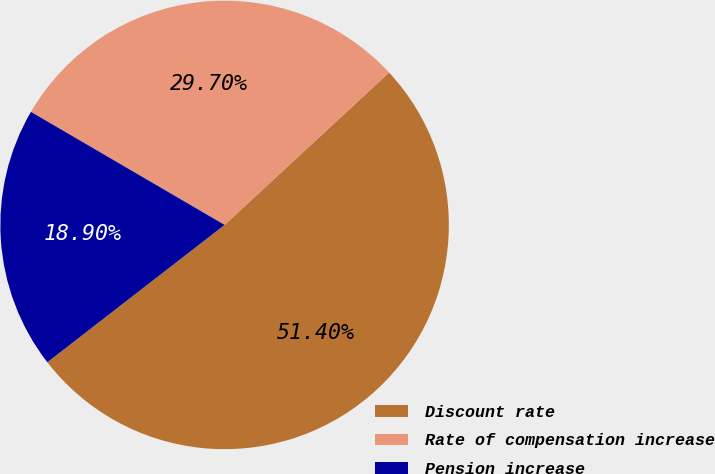Convert chart to OTSL. <chart><loc_0><loc_0><loc_500><loc_500><pie_chart><fcel>Discount rate<fcel>Rate of compensation increase<fcel>Pension increase<nl><fcel>51.4%<fcel>29.7%<fcel>18.9%<nl></chart> 